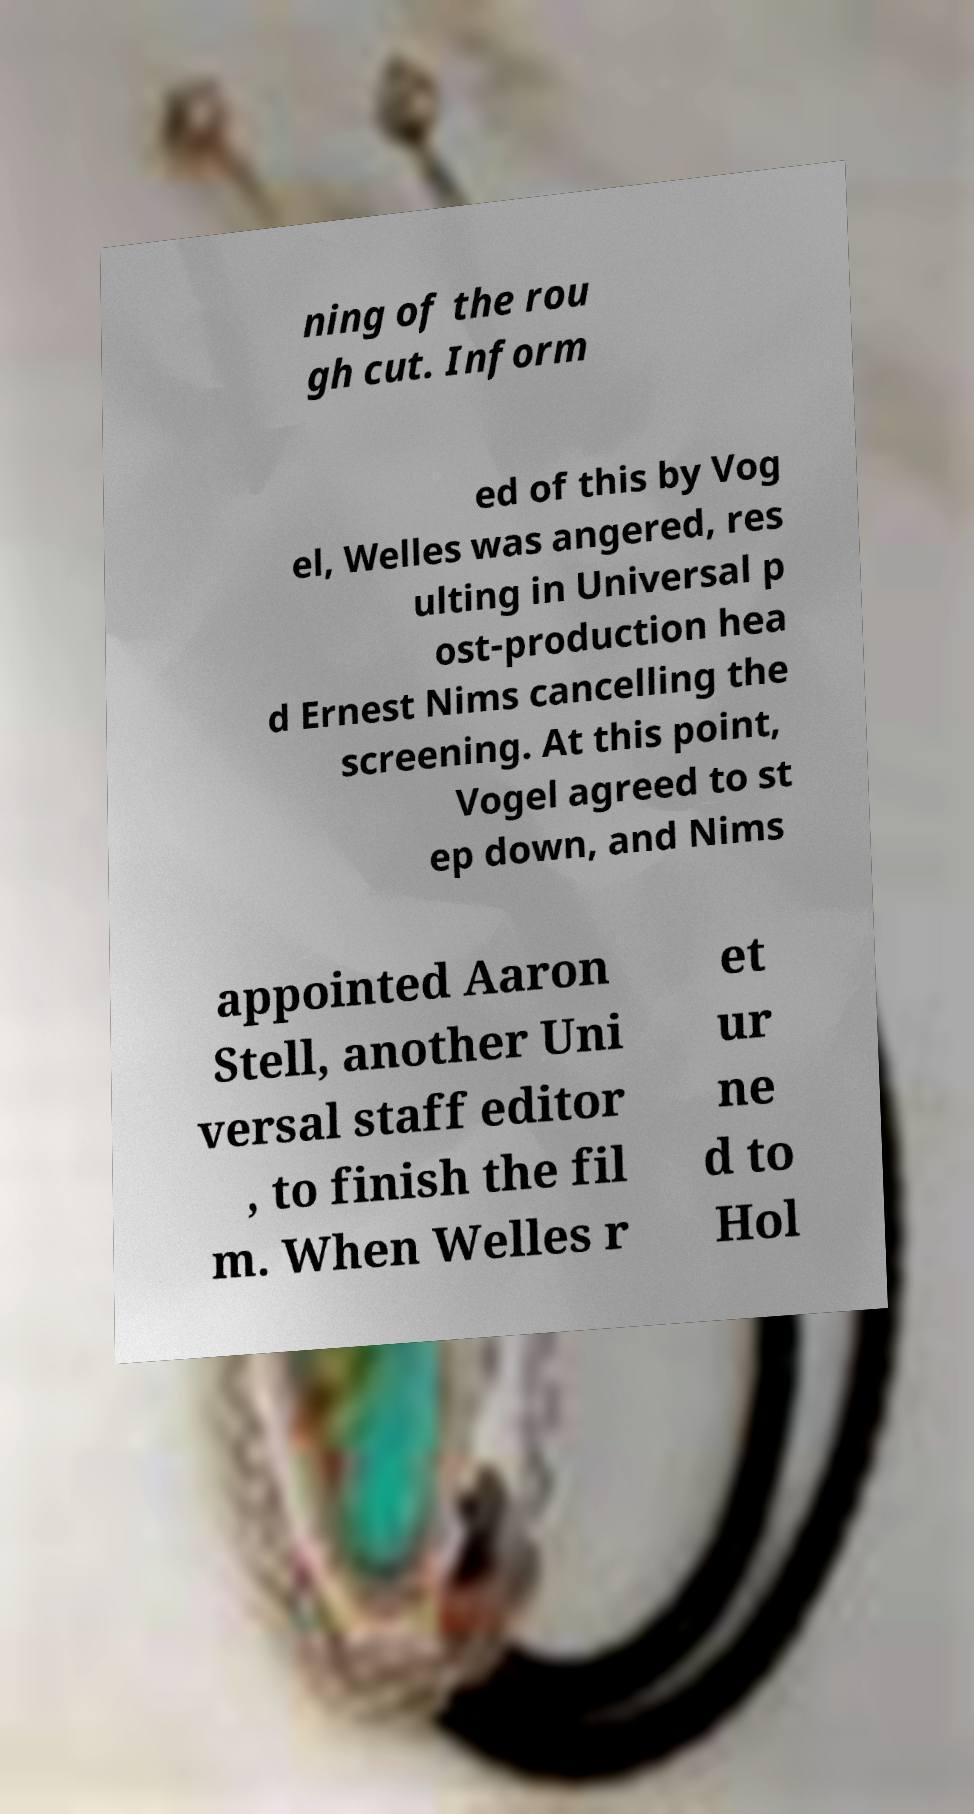Please read and relay the text visible in this image. What does it say? ning of the rou gh cut. Inform ed of this by Vog el, Welles was angered, res ulting in Universal p ost-production hea d Ernest Nims cancelling the screening. At this point, Vogel agreed to st ep down, and Nims appointed Aaron Stell, another Uni versal staff editor , to finish the fil m. When Welles r et ur ne d to Hol 